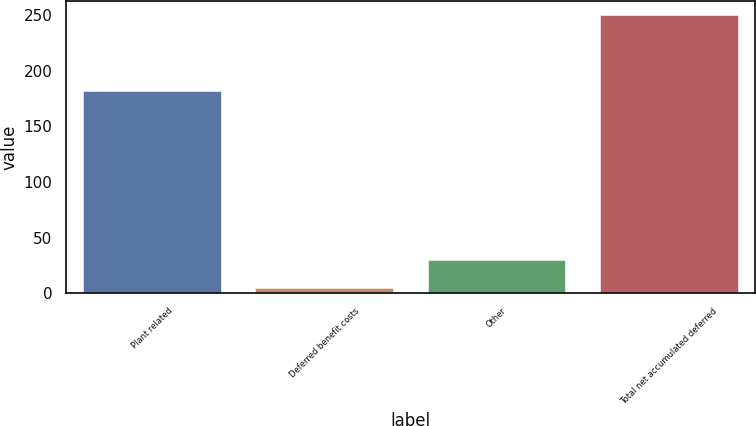Convert chart. <chart><loc_0><loc_0><loc_500><loc_500><bar_chart><fcel>Plant related<fcel>Deferred benefit costs<fcel>Other<fcel>Total net accumulated deferred<nl><fcel>182<fcel>5<fcel>29.8<fcel>250<nl></chart> 